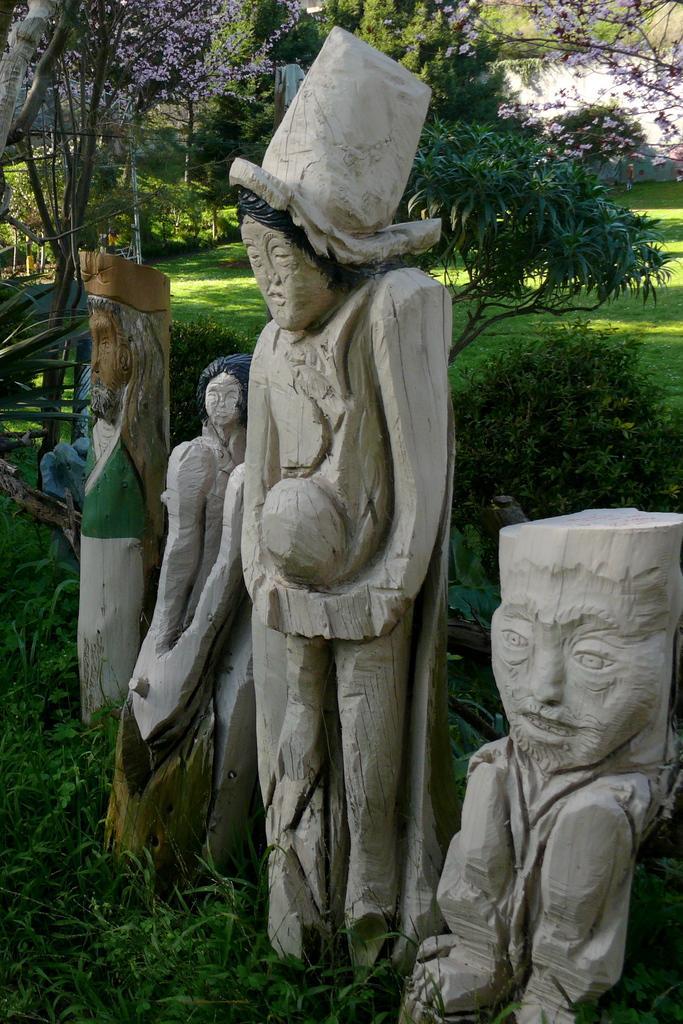Describe this image in one or two sentences. Here we can see statues. Background there are trees, plants and grass. 